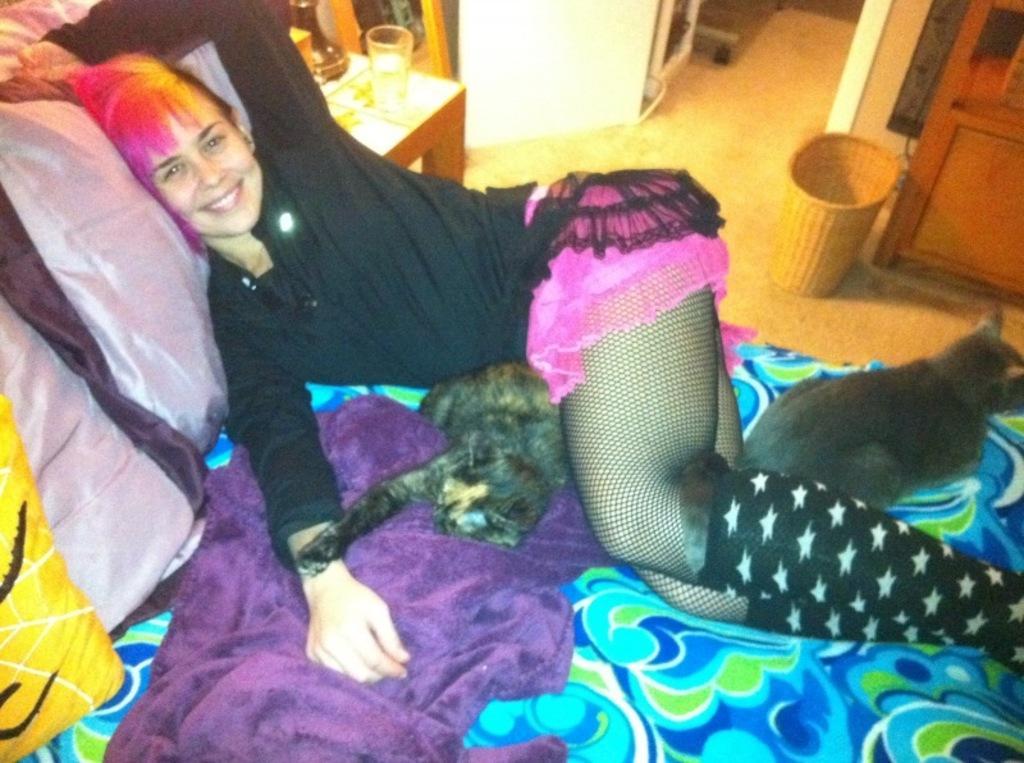Please provide a concise description of this image. In this image I see a woman who is lying on the bed and she is smiling. I can also see 2 cats on the bed. In the background I see the table and there is a glass on it. 